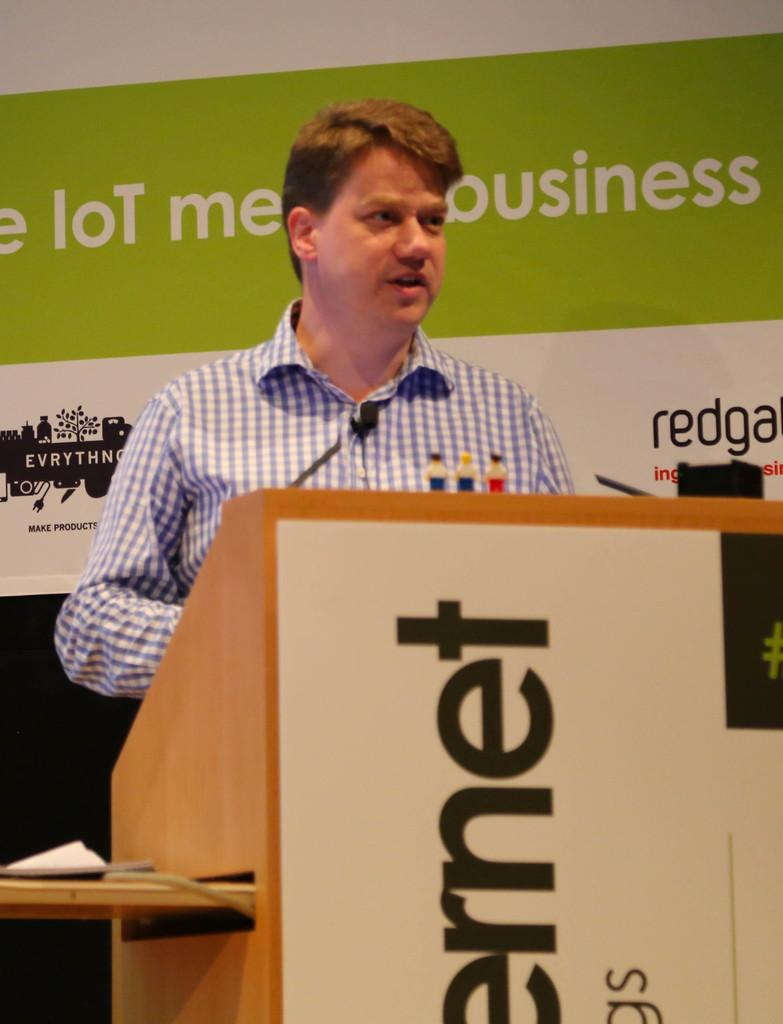<image>
Present a compact description of the photo's key features. A man stands at a podium; above his head the word business is visible. 